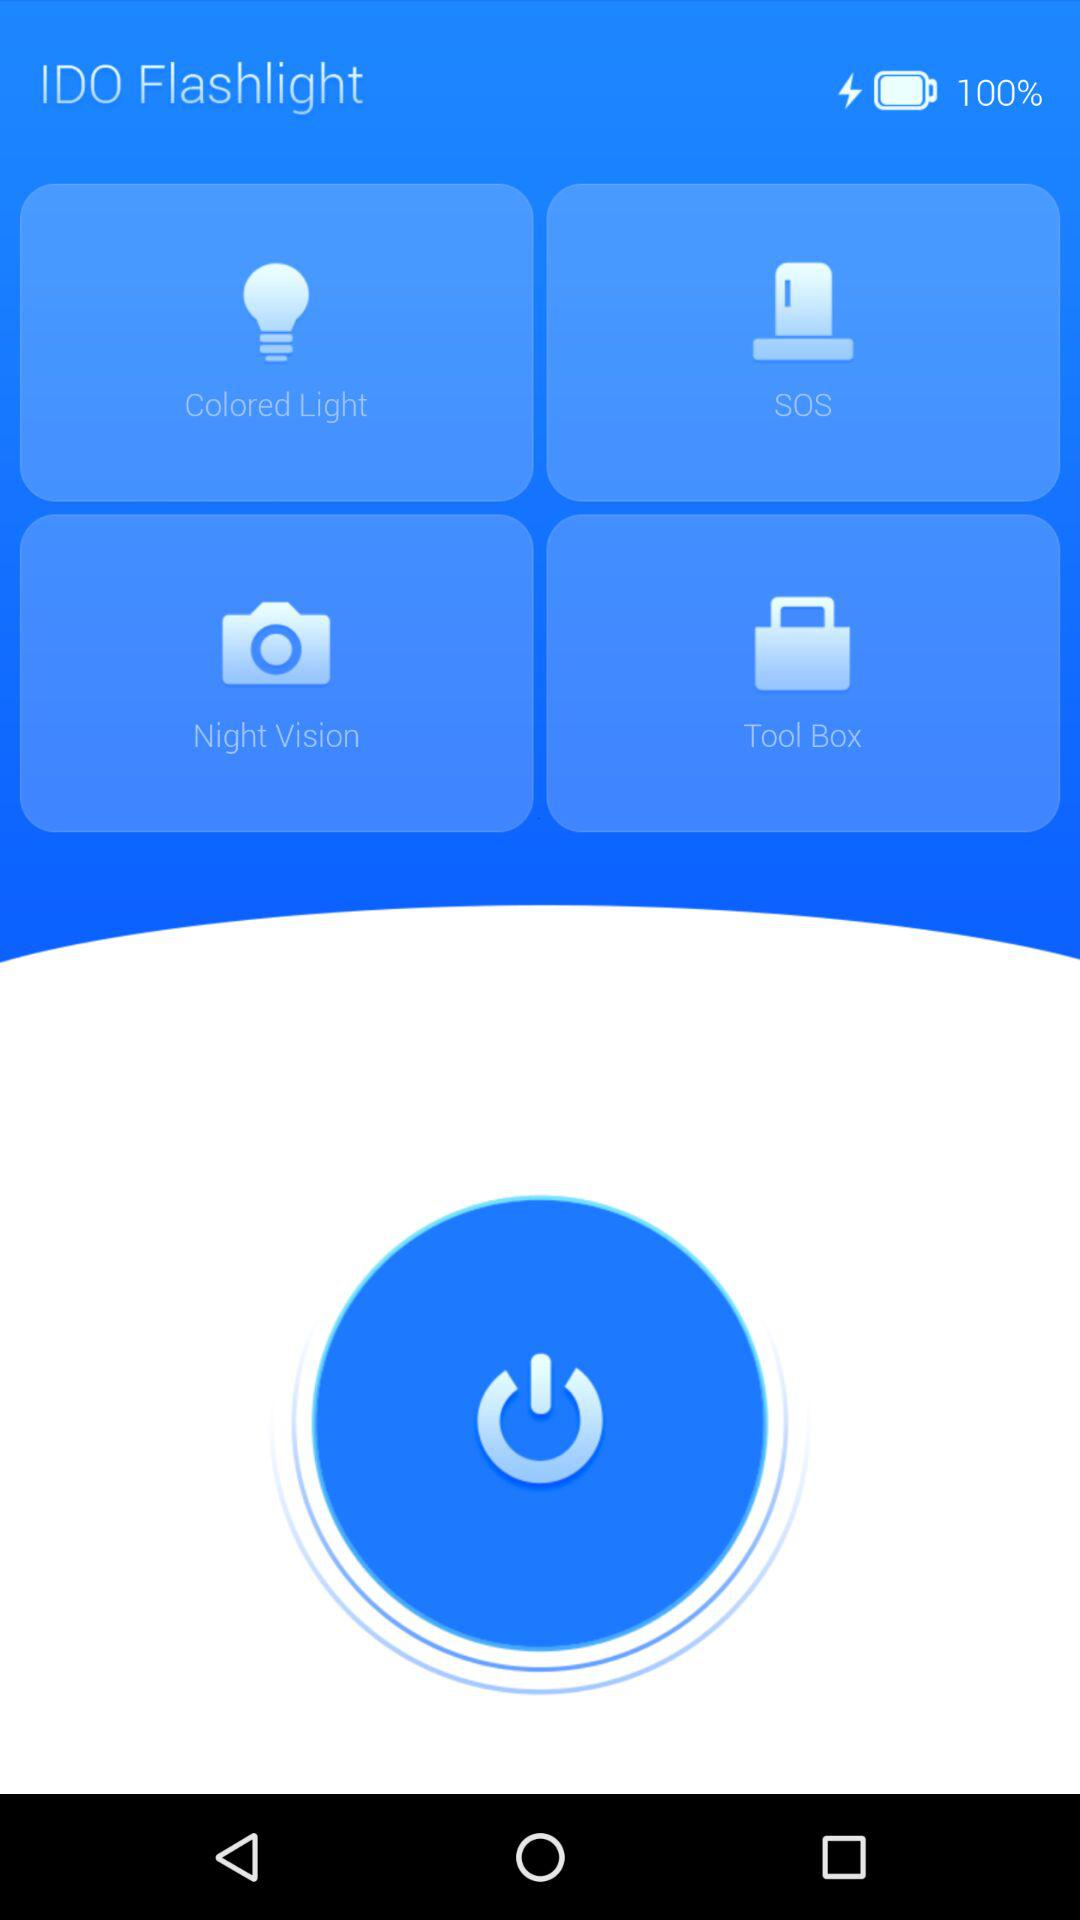What is the name of the application? The name of the application is "IDO Flashlight". 